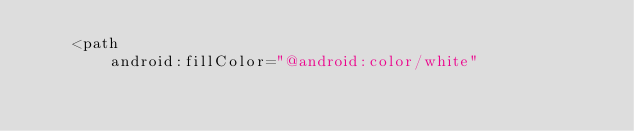Convert code to text. <code><loc_0><loc_0><loc_500><loc_500><_XML_>    <path
        android:fillColor="@android:color/white"</code> 